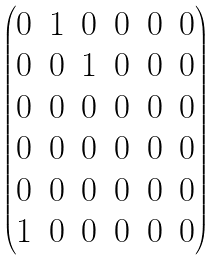<formula> <loc_0><loc_0><loc_500><loc_500>\begin{pmatrix} 0 & 1 & 0 & 0 & 0 & 0 \\ 0 & 0 & 1 & 0 & 0 & 0 \\ 0 & 0 & 0 & 0 & 0 & 0 \\ 0 & 0 & 0 & 0 & 0 & 0 \\ 0 & 0 & 0 & 0 & 0 & 0 \\ 1 & 0 & 0 & 0 & 0 & 0 \end{pmatrix}</formula> 